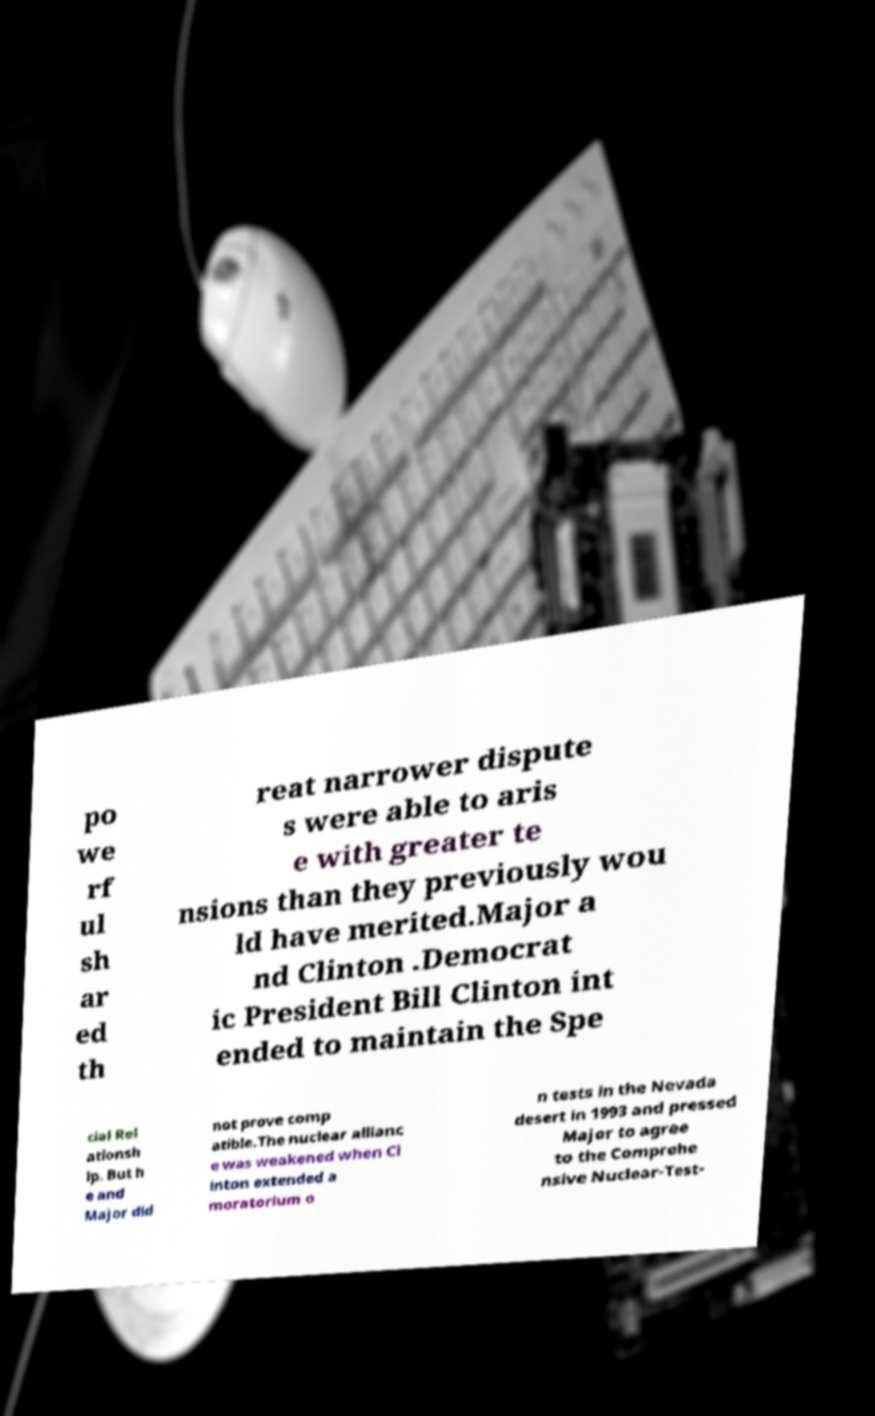What messages or text are displayed in this image? I need them in a readable, typed format. po we rf ul sh ar ed th reat narrower dispute s were able to aris e with greater te nsions than they previously wou ld have merited.Major a nd Clinton .Democrat ic President Bill Clinton int ended to maintain the Spe cial Rel ationsh ip. But h e and Major did not prove comp atible.The nuclear allianc e was weakened when Cl inton extended a moratorium o n tests in the Nevada desert in 1993 and pressed Major to agree to the Comprehe nsive Nuclear-Test- 